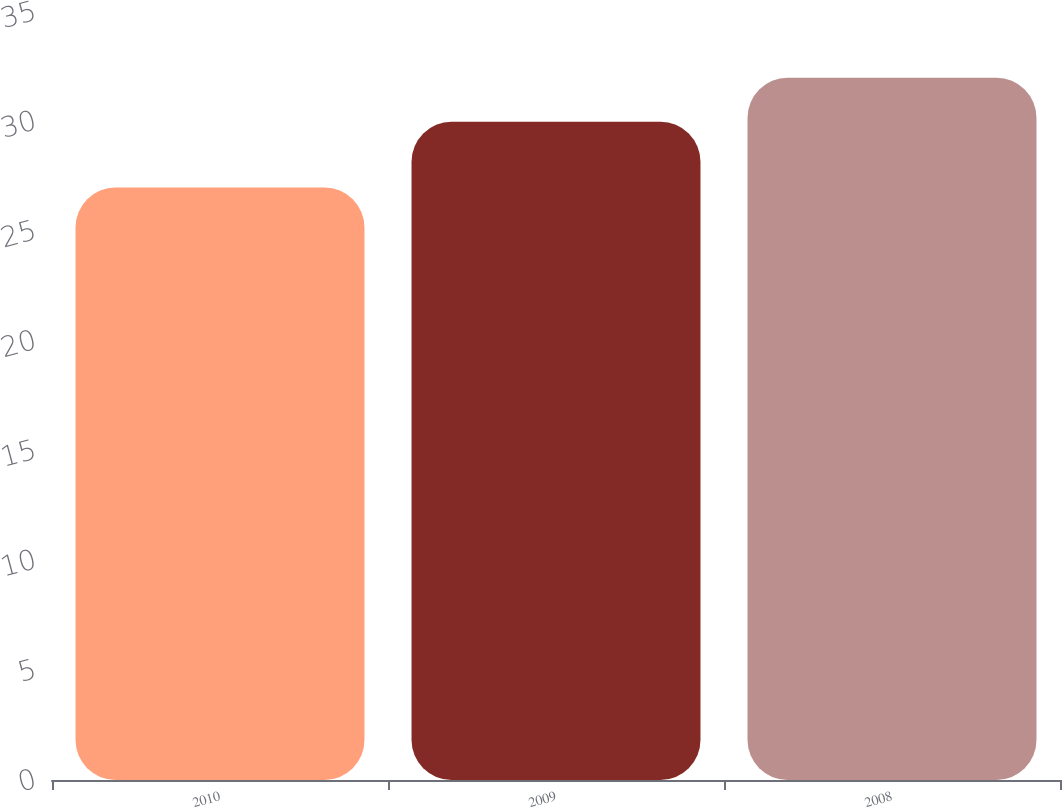Convert chart. <chart><loc_0><loc_0><loc_500><loc_500><bar_chart><fcel>2010<fcel>2009<fcel>2008<nl><fcel>27<fcel>30<fcel>32<nl></chart> 